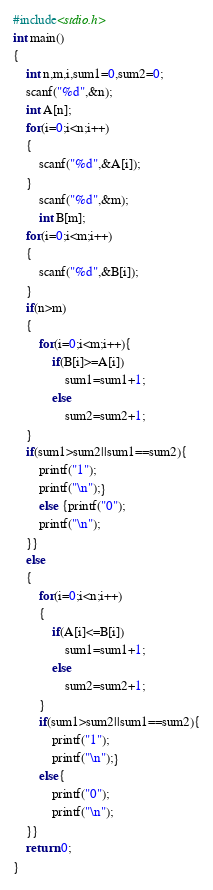Convert code to text. <code><loc_0><loc_0><loc_500><loc_500><_C_>#include<stdio.h>
int main()
{
    int n,m,i,sum1=0,sum2=0;
    scanf("%d",&n);
    int A[n];
    for(i=0;i<n;i++)
    {
        scanf("%d",&A[i]);
    }
        scanf("%d",&m);
        int B[m];
    for(i=0;i<m;i++)
    {
        scanf("%d",&B[i]);
    }
    if(n>m)
    {
        for(i=0;i<m;i++){
            if(B[i]>=A[i])
                sum1=sum1+1;
            else
                sum2=sum2+1;
    }
    if(sum1>sum2||sum1==sum2){
        printf("1");
        printf("\n");}
        else {printf("0");
        printf("\n");
    }}
    else
    {
        for(i=0;i<n;i++)
        {
            if(A[i]<=B[i])
                sum1=sum1+1;
            else
                sum2=sum2+1;
        }
        if(sum1>sum2||sum1==sum2){
            printf("1");
            printf("\n");}
        else{
            printf("0");
            printf("\n");
    }}
    return 0;
}

</code> 